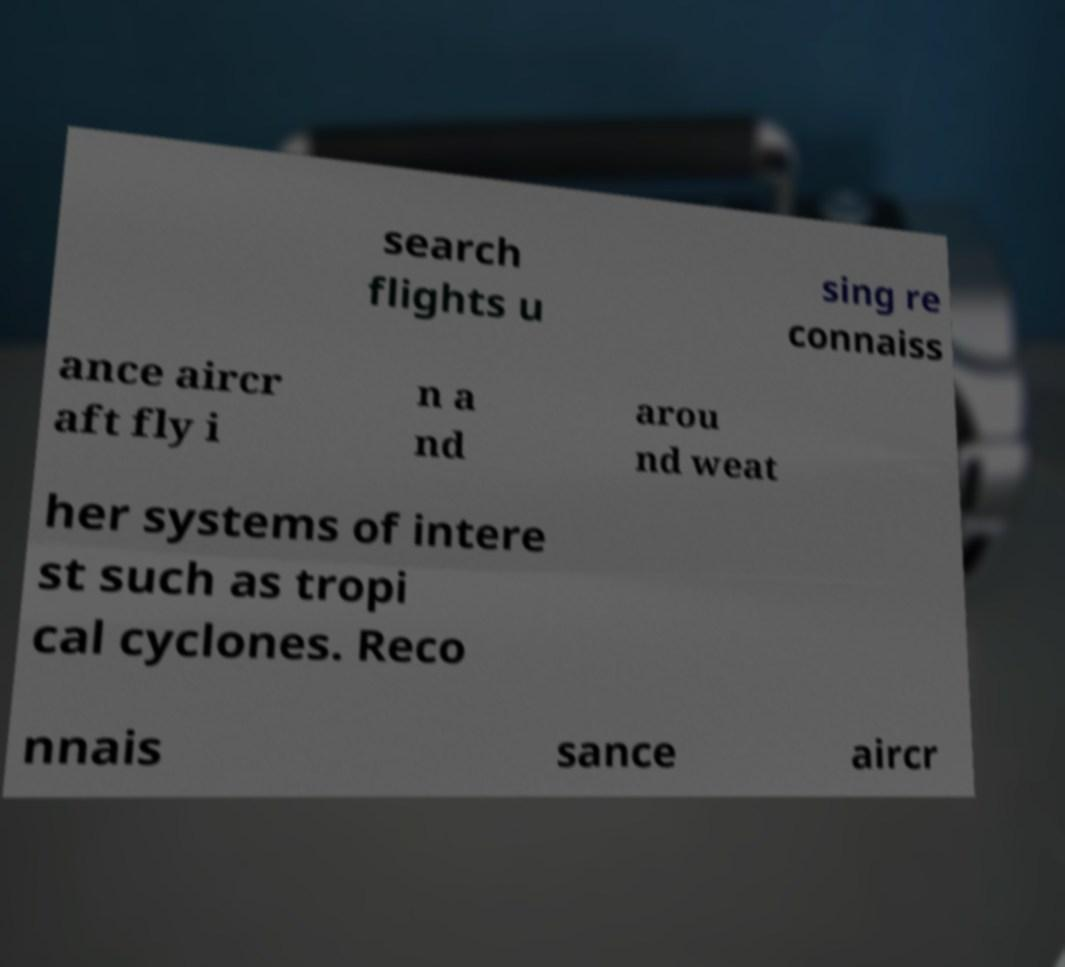Please identify and transcribe the text found in this image. search flights u sing re connaiss ance aircr aft fly i n a nd arou nd weat her systems of intere st such as tropi cal cyclones. Reco nnais sance aircr 